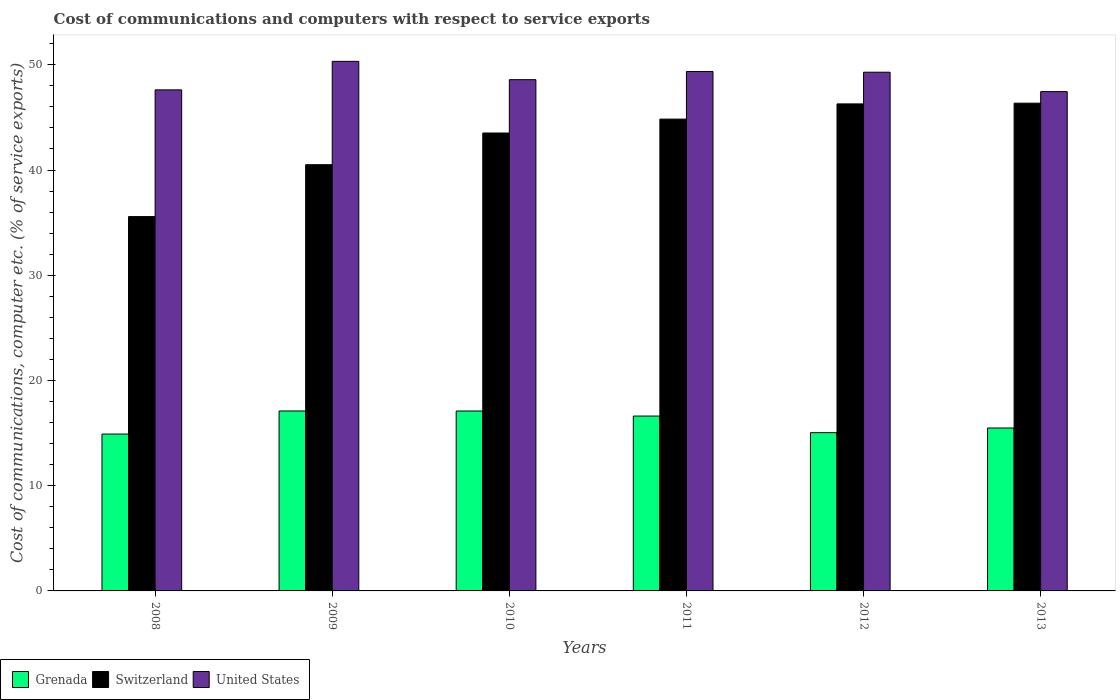How many different coloured bars are there?
Ensure brevity in your answer.  3. How many groups of bars are there?
Offer a very short reply. 6. How many bars are there on the 3rd tick from the right?
Provide a succinct answer. 3. What is the label of the 1st group of bars from the left?
Provide a succinct answer. 2008. In how many cases, is the number of bars for a given year not equal to the number of legend labels?
Provide a succinct answer. 0. What is the cost of communications and computers in United States in 2008?
Provide a succinct answer. 47.62. Across all years, what is the maximum cost of communications and computers in United States?
Your response must be concise. 50.33. Across all years, what is the minimum cost of communications and computers in Grenada?
Provide a short and direct response. 14.91. In which year was the cost of communications and computers in Grenada maximum?
Provide a succinct answer. 2009. What is the total cost of communications and computers in Grenada in the graph?
Offer a very short reply. 96.25. What is the difference between the cost of communications and computers in Grenada in 2009 and that in 2010?
Ensure brevity in your answer.  0. What is the difference between the cost of communications and computers in United States in 2009 and the cost of communications and computers in Switzerland in 2012?
Give a very brief answer. 4.04. What is the average cost of communications and computers in Grenada per year?
Provide a succinct answer. 16.04. In the year 2009, what is the difference between the cost of communications and computers in United States and cost of communications and computers in Grenada?
Provide a short and direct response. 33.23. In how many years, is the cost of communications and computers in Switzerland greater than 16 %?
Offer a very short reply. 6. What is the ratio of the cost of communications and computers in Grenada in 2011 to that in 2012?
Offer a terse response. 1.1. What is the difference between the highest and the second highest cost of communications and computers in Grenada?
Your response must be concise. 0. What is the difference between the highest and the lowest cost of communications and computers in Switzerland?
Your answer should be very brief. 10.78. Is the sum of the cost of communications and computers in United States in 2010 and 2012 greater than the maximum cost of communications and computers in Switzerland across all years?
Ensure brevity in your answer.  Yes. What does the 1st bar from the left in 2012 represents?
Keep it short and to the point. Grenada. What does the 3rd bar from the right in 2011 represents?
Ensure brevity in your answer.  Grenada. Is it the case that in every year, the sum of the cost of communications and computers in Grenada and cost of communications and computers in Switzerland is greater than the cost of communications and computers in United States?
Your answer should be very brief. Yes. How many bars are there?
Your response must be concise. 18. Are all the bars in the graph horizontal?
Ensure brevity in your answer.  No. How many years are there in the graph?
Make the answer very short. 6. Does the graph contain grids?
Offer a very short reply. No. How are the legend labels stacked?
Make the answer very short. Horizontal. What is the title of the graph?
Your answer should be compact. Cost of communications and computers with respect to service exports. What is the label or title of the X-axis?
Give a very brief answer. Years. What is the label or title of the Y-axis?
Provide a short and direct response. Cost of communications, computer etc. (% of service exports). What is the Cost of communications, computer etc. (% of service exports) in Grenada in 2008?
Your answer should be compact. 14.91. What is the Cost of communications, computer etc. (% of service exports) of Switzerland in 2008?
Your answer should be very brief. 35.58. What is the Cost of communications, computer etc. (% of service exports) of United States in 2008?
Your response must be concise. 47.62. What is the Cost of communications, computer etc. (% of service exports) in Grenada in 2009?
Offer a very short reply. 17.1. What is the Cost of communications, computer etc. (% of service exports) of Switzerland in 2009?
Give a very brief answer. 40.51. What is the Cost of communications, computer etc. (% of service exports) in United States in 2009?
Keep it short and to the point. 50.33. What is the Cost of communications, computer etc. (% of service exports) in Grenada in 2010?
Provide a succinct answer. 17.1. What is the Cost of communications, computer etc. (% of service exports) in Switzerland in 2010?
Provide a succinct answer. 43.52. What is the Cost of communications, computer etc. (% of service exports) of United States in 2010?
Your answer should be compact. 48.59. What is the Cost of communications, computer etc. (% of service exports) of Grenada in 2011?
Offer a terse response. 16.62. What is the Cost of communications, computer etc. (% of service exports) of Switzerland in 2011?
Make the answer very short. 44.84. What is the Cost of communications, computer etc. (% of service exports) of United States in 2011?
Your response must be concise. 49.37. What is the Cost of communications, computer etc. (% of service exports) of Grenada in 2012?
Make the answer very short. 15.04. What is the Cost of communications, computer etc. (% of service exports) of Switzerland in 2012?
Your answer should be compact. 46.29. What is the Cost of communications, computer etc. (% of service exports) of United States in 2012?
Provide a short and direct response. 49.3. What is the Cost of communications, computer etc. (% of service exports) of Grenada in 2013?
Make the answer very short. 15.48. What is the Cost of communications, computer etc. (% of service exports) of Switzerland in 2013?
Make the answer very short. 46.35. What is the Cost of communications, computer etc. (% of service exports) in United States in 2013?
Your answer should be very brief. 47.45. Across all years, what is the maximum Cost of communications, computer etc. (% of service exports) of Grenada?
Ensure brevity in your answer.  17.1. Across all years, what is the maximum Cost of communications, computer etc. (% of service exports) in Switzerland?
Your answer should be compact. 46.35. Across all years, what is the maximum Cost of communications, computer etc. (% of service exports) in United States?
Ensure brevity in your answer.  50.33. Across all years, what is the minimum Cost of communications, computer etc. (% of service exports) of Grenada?
Provide a short and direct response. 14.91. Across all years, what is the minimum Cost of communications, computer etc. (% of service exports) of Switzerland?
Your answer should be compact. 35.58. Across all years, what is the minimum Cost of communications, computer etc. (% of service exports) of United States?
Make the answer very short. 47.45. What is the total Cost of communications, computer etc. (% of service exports) in Grenada in the graph?
Make the answer very short. 96.25. What is the total Cost of communications, computer etc. (% of service exports) in Switzerland in the graph?
Offer a terse response. 257.08. What is the total Cost of communications, computer etc. (% of service exports) in United States in the graph?
Your answer should be compact. 292.66. What is the difference between the Cost of communications, computer etc. (% of service exports) of Grenada in 2008 and that in 2009?
Your answer should be compact. -2.19. What is the difference between the Cost of communications, computer etc. (% of service exports) in Switzerland in 2008 and that in 2009?
Your answer should be very brief. -4.93. What is the difference between the Cost of communications, computer etc. (% of service exports) of United States in 2008 and that in 2009?
Ensure brevity in your answer.  -2.71. What is the difference between the Cost of communications, computer etc. (% of service exports) in Grenada in 2008 and that in 2010?
Keep it short and to the point. -2.19. What is the difference between the Cost of communications, computer etc. (% of service exports) in Switzerland in 2008 and that in 2010?
Offer a terse response. -7.94. What is the difference between the Cost of communications, computer etc. (% of service exports) of United States in 2008 and that in 2010?
Offer a terse response. -0.97. What is the difference between the Cost of communications, computer etc. (% of service exports) in Grenada in 2008 and that in 2011?
Offer a very short reply. -1.71. What is the difference between the Cost of communications, computer etc. (% of service exports) in Switzerland in 2008 and that in 2011?
Offer a very short reply. -9.26. What is the difference between the Cost of communications, computer etc. (% of service exports) of United States in 2008 and that in 2011?
Make the answer very short. -1.75. What is the difference between the Cost of communications, computer etc. (% of service exports) in Grenada in 2008 and that in 2012?
Offer a terse response. -0.13. What is the difference between the Cost of communications, computer etc. (% of service exports) in Switzerland in 2008 and that in 2012?
Provide a short and direct response. -10.71. What is the difference between the Cost of communications, computer etc. (% of service exports) in United States in 2008 and that in 2012?
Your answer should be very brief. -1.68. What is the difference between the Cost of communications, computer etc. (% of service exports) of Grenada in 2008 and that in 2013?
Offer a very short reply. -0.58. What is the difference between the Cost of communications, computer etc. (% of service exports) of Switzerland in 2008 and that in 2013?
Provide a short and direct response. -10.78. What is the difference between the Cost of communications, computer etc. (% of service exports) of United States in 2008 and that in 2013?
Ensure brevity in your answer.  0.17. What is the difference between the Cost of communications, computer etc. (% of service exports) in Grenada in 2009 and that in 2010?
Make the answer very short. 0. What is the difference between the Cost of communications, computer etc. (% of service exports) of Switzerland in 2009 and that in 2010?
Make the answer very short. -3.01. What is the difference between the Cost of communications, computer etc. (% of service exports) of United States in 2009 and that in 2010?
Offer a very short reply. 1.74. What is the difference between the Cost of communications, computer etc. (% of service exports) of Grenada in 2009 and that in 2011?
Ensure brevity in your answer.  0.48. What is the difference between the Cost of communications, computer etc. (% of service exports) of Switzerland in 2009 and that in 2011?
Make the answer very short. -4.33. What is the difference between the Cost of communications, computer etc. (% of service exports) of United States in 2009 and that in 2011?
Your answer should be very brief. 0.96. What is the difference between the Cost of communications, computer etc. (% of service exports) in Grenada in 2009 and that in 2012?
Your answer should be compact. 2.06. What is the difference between the Cost of communications, computer etc. (% of service exports) of Switzerland in 2009 and that in 2012?
Your response must be concise. -5.78. What is the difference between the Cost of communications, computer etc. (% of service exports) of United States in 2009 and that in 2012?
Provide a short and direct response. 1.03. What is the difference between the Cost of communications, computer etc. (% of service exports) in Grenada in 2009 and that in 2013?
Your answer should be very brief. 1.62. What is the difference between the Cost of communications, computer etc. (% of service exports) in Switzerland in 2009 and that in 2013?
Offer a terse response. -5.85. What is the difference between the Cost of communications, computer etc. (% of service exports) in United States in 2009 and that in 2013?
Provide a short and direct response. 2.88. What is the difference between the Cost of communications, computer etc. (% of service exports) in Grenada in 2010 and that in 2011?
Your response must be concise. 0.48. What is the difference between the Cost of communications, computer etc. (% of service exports) of Switzerland in 2010 and that in 2011?
Your answer should be compact. -1.32. What is the difference between the Cost of communications, computer etc. (% of service exports) of United States in 2010 and that in 2011?
Give a very brief answer. -0.78. What is the difference between the Cost of communications, computer etc. (% of service exports) in Grenada in 2010 and that in 2012?
Ensure brevity in your answer.  2.06. What is the difference between the Cost of communications, computer etc. (% of service exports) in Switzerland in 2010 and that in 2012?
Make the answer very short. -2.77. What is the difference between the Cost of communications, computer etc. (% of service exports) in United States in 2010 and that in 2012?
Offer a terse response. -0.71. What is the difference between the Cost of communications, computer etc. (% of service exports) in Grenada in 2010 and that in 2013?
Provide a short and direct response. 1.61. What is the difference between the Cost of communications, computer etc. (% of service exports) of Switzerland in 2010 and that in 2013?
Keep it short and to the point. -2.84. What is the difference between the Cost of communications, computer etc. (% of service exports) of United States in 2010 and that in 2013?
Your answer should be compact. 1.14. What is the difference between the Cost of communications, computer etc. (% of service exports) of Grenada in 2011 and that in 2012?
Provide a short and direct response. 1.58. What is the difference between the Cost of communications, computer etc. (% of service exports) in Switzerland in 2011 and that in 2012?
Provide a succinct answer. -1.45. What is the difference between the Cost of communications, computer etc. (% of service exports) of United States in 2011 and that in 2012?
Keep it short and to the point. 0.07. What is the difference between the Cost of communications, computer etc. (% of service exports) in Grenada in 2011 and that in 2013?
Your answer should be very brief. 1.14. What is the difference between the Cost of communications, computer etc. (% of service exports) of Switzerland in 2011 and that in 2013?
Your answer should be compact. -1.52. What is the difference between the Cost of communications, computer etc. (% of service exports) in United States in 2011 and that in 2013?
Keep it short and to the point. 1.91. What is the difference between the Cost of communications, computer etc. (% of service exports) in Grenada in 2012 and that in 2013?
Keep it short and to the point. -0.44. What is the difference between the Cost of communications, computer etc. (% of service exports) of Switzerland in 2012 and that in 2013?
Ensure brevity in your answer.  -0.07. What is the difference between the Cost of communications, computer etc. (% of service exports) in United States in 2012 and that in 2013?
Your answer should be compact. 1.84. What is the difference between the Cost of communications, computer etc. (% of service exports) of Grenada in 2008 and the Cost of communications, computer etc. (% of service exports) of Switzerland in 2009?
Your response must be concise. -25.6. What is the difference between the Cost of communications, computer etc. (% of service exports) of Grenada in 2008 and the Cost of communications, computer etc. (% of service exports) of United States in 2009?
Your answer should be compact. -35.42. What is the difference between the Cost of communications, computer etc. (% of service exports) in Switzerland in 2008 and the Cost of communications, computer etc. (% of service exports) in United States in 2009?
Provide a succinct answer. -14.75. What is the difference between the Cost of communications, computer etc. (% of service exports) in Grenada in 2008 and the Cost of communications, computer etc. (% of service exports) in Switzerland in 2010?
Provide a succinct answer. -28.61. What is the difference between the Cost of communications, computer etc. (% of service exports) in Grenada in 2008 and the Cost of communications, computer etc. (% of service exports) in United States in 2010?
Make the answer very short. -33.68. What is the difference between the Cost of communications, computer etc. (% of service exports) of Switzerland in 2008 and the Cost of communications, computer etc. (% of service exports) of United States in 2010?
Provide a short and direct response. -13.01. What is the difference between the Cost of communications, computer etc. (% of service exports) of Grenada in 2008 and the Cost of communications, computer etc. (% of service exports) of Switzerland in 2011?
Offer a very short reply. -29.93. What is the difference between the Cost of communications, computer etc. (% of service exports) of Grenada in 2008 and the Cost of communications, computer etc. (% of service exports) of United States in 2011?
Your answer should be very brief. -34.46. What is the difference between the Cost of communications, computer etc. (% of service exports) of Switzerland in 2008 and the Cost of communications, computer etc. (% of service exports) of United States in 2011?
Your response must be concise. -13.79. What is the difference between the Cost of communications, computer etc. (% of service exports) in Grenada in 2008 and the Cost of communications, computer etc. (% of service exports) in Switzerland in 2012?
Offer a very short reply. -31.38. What is the difference between the Cost of communications, computer etc. (% of service exports) of Grenada in 2008 and the Cost of communications, computer etc. (% of service exports) of United States in 2012?
Provide a succinct answer. -34.39. What is the difference between the Cost of communications, computer etc. (% of service exports) in Switzerland in 2008 and the Cost of communications, computer etc. (% of service exports) in United States in 2012?
Offer a terse response. -13.72. What is the difference between the Cost of communications, computer etc. (% of service exports) of Grenada in 2008 and the Cost of communications, computer etc. (% of service exports) of Switzerland in 2013?
Make the answer very short. -31.45. What is the difference between the Cost of communications, computer etc. (% of service exports) in Grenada in 2008 and the Cost of communications, computer etc. (% of service exports) in United States in 2013?
Provide a succinct answer. -32.55. What is the difference between the Cost of communications, computer etc. (% of service exports) in Switzerland in 2008 and the Cost of communications, computer etc. (% of service exports) in United States in 2013?
Offer a terse response. -11.88. What is the difference between the Cost of communications, computer etc. (% of service exports) in Grenada in 2009 and the Cost of communications, computer etc. (% of service exports) in Switzerland in 2010?
Ensure brevity in your answer.  -26.42. What is the difference between the Cost of communications, computer etc. (% of service exports) in Grenada in 2009 and the Cost of communications, computer etc. (% of service exports) in United States in 2010?
Make the answer very short. -31.49. What is the difference between the Cost of communications, computer etc. (% of service exports) of Switzerland in 2009 and the Cost of communications, computer etc. (% of service exports) of United States in 2010?
Make the answer very short. -8.08. What is the difference between the Cost of communications, computer etc. (% of service exports) of Grenada in 2009 and the Cost of communications, computer etc. (% of service exports) of Switzerland in 2011?
Provide a short and direct response. -27.74. What is the difference between the Cost of communications, computer etc. (% of service exports) of Grenada in 2009 and the Cost of communications, computer etc. (% of service exports) of United States in 2011?
Your answer should be very brief. -32.26. What is the difference between the Cost of communications, computer etc. (% of service exports) of Switzerland in 2009 and the Cost of communications, computer etc. (% of service exports) of United States in 2011?
Your answer should be very brief. -8.86. What is the difference between the Cost of communications, computer etc. (% of service exports) of Grenada in 2009 and the Cost of communications, computer etc. (% of service exports) of Switzerland in 2012?
Your response must be concise. -29.18. What is the difference between the Cost of communications, computer etc. (% of service exports) in Grenada in 2009 and the Cost of communications, computer etc. (% of service exports) in United States in 2012?
Give a very brief answer. -32.2. What is the difference between the Cost of communications, computer etc. (% of service exports) in Switzerland in 2009 and the Cost of communications, computer etc. (% of service exports) in United States in 2012?
Give a very brief answer. -8.79. What is the difference between the Cost of communications, computer etc. (% of service exports) in Grenada in 2009 and the Cost of communications, computer etc. (% of service exports) in Switzerland in 2013?
Ensure brevity in your answer.  -29.25. What is the difference between the Cost of communications, computer etc. (% of service exports) of Grenada in 2009 and the Cost of communications, computer etc. (% of service exports) of United States in 2013?
Offer a terse response. -30.35. What is the difference between the Cost of communications, computer etc. (% of service exports) of Switzerland in 2009 and the Cost of communications, computer etc. (% of service exports) of United States in 2013?
Ensure brevity in your answer.  -6.95. What is the difference between the Cost of communications, computer etc. (% of service exports) in Grenada in 2010 and the Cost of communications, computer etc. (% of service exports) in Switzerland in 2011?
Provide a succinct answer. -27.74. What is the difference between the Cost of communications, computer etc. (% of service exports) of Grenada in 2010 and the Cost of communications, computer etc. (% of service exports) of United States in 2011?
Ensure brevity in your answer.  -32.27. What is the difference between the Cost of communications, computer etc. (% of service exports) of Switzerland in 2010 and the Cost of communications, computer etc. (% of service exports) of United States in 2011?
Provide a succinct answer. -5.85. What is the difference between the Cost of communications, computer etc. (% of service exports) of Grenada in 2010 and the Cost of communications, computer etc. (% of service exports) of Switzerland in 2012?
Make the answer very short. -29.19. What is the difference between the Cost of communications, computer etc. (% of service exports) of Grenada in 2010 and the Cost of communications, computer etc. (% of service exports) of United States in 2012?
Provide a short and direct response. -32.2. What is the difference between the Cost of communications, computer etc. (% of service exports) of Switzerland in 2010 and the Cost of communications, computer etc. (% of service exports) of United States in 2012?
Provide a succinct answer. -5.78. What is the difference between the Cost of communications, computer etc. (% of service exports) of Grenada in 2010 and the Cost of communications, computer etc. (% of service exports) of Switzerland in 2013?
Your answer should be compact. -29.26. What is the difference between the Cost of communications, computer etc. (% of service exports) of Grenada in 2010 and the Cost of communications, computer etc. (% of service exports) of United States in 2013?
Your answer should be very brief. -30.36. What is the difference between the Cost of communications, computer etc. (% of service exports) of Switzerland in 2010 and the Cost of communications, computer etc. (% of service exports) of United States in 2013?
Keep it short and to the point. -3.93. What is the difference between the Cost of communications, computer etc. (% of service exports) in Grenada in 2011 and the Cost of communications, computer etc. (% of service exports) in Switzerland in 2012?
Your response must be concise. -29.67. What is the difference between the Cost of communications, computer etc. (% of service exports) of Grenada in 2011 and the Cost of communications, computer etc. (% of service exports) of United States in 2012?
Ensure brevity in your answer.  -32.68. What is the difference between the Cost of communications, computer etc. (% of service exports) in Switzerland in 2011 and the Cost of communications, computer etc. (% of service exports) in United States in 2012?
Provide a succinct answer. -4.46. What is the difference between the Cost of communications, computer etc. (% of service exports) in Grenada in 2011 and the Cost of communications, computer etc. (% of service exports) in Switzerland in 2013?
Your answer should be compact. -29.73. What is the difference between the Cost of communications, computer etc. (% of service exports) of Grenada in 2011 and the Cost of communications, computer etc. (% of service exports) of United States in 2013?
Your response must be concise. -30.83. What is the difference between the Cost of communications, computer etc. (% of service exports) in Switzerland in 2011 and the Cost of communications, computer etc. (% of service exports) in United States in 2013?
Make the answer very short. -2.61. What is the difference between the Cost of communications, computer etc. (% of service exports) of Grenada in 2012 and the Cost of communications, computer etc. (% of service exports) of Switzerland in 2013?
Give a very brief answer. -31.31. What is the difference between the Cost of communications, computer etc. (% of service exports) in Grenada in 2012 and the Cost of communications, computer etc. (% of service exports) in United States in 2013?
Your response must be concise. -32.41. What is the difference between the Cost of communications, computer etc. (% of service exports) in Switzerland in 2012 and the Cost of communications, computer etc. (% of service exports) in United States in 2013?
Offer a terse response. -1.17. What is the average Cost of communications, computer etc. (% of service exports) in Grenada per year?
Provide a succinct answer. 16.04. What is the average Cost of communications, computer etc. (% of service exports) in Switzerland per year?
Offer a very short reply. 42.85. What is the average Cost of communications, computer etc. (% of service exports) in United States per year?
Provide a short and direct response. 48.78. In the year 2008, what is the difference between the Cost of communications, computer etc. (% of service exports) in Grenada and Cost of communications, computer etc. (% of service exports) in Switzerland?
Keep it short and to the point. -20.67. In the year 2008, what is the difference between the Cost of communications, computer etc. (% of service exports) of Grenada and Cost of communications, computer etc. (% of service exports) of United States?
Make the answer very short. -32.71. In the year 2008, what is the difference between the Cost of communications, computer etc. (% of service exports) of Switzerland and Cost of communications, computer etc. (% of service exports) of United States?
Offer a very short reply. -12.04. In the year 2009, what is the difference between the Cost of communications, computer etc. (% of service exports) in Grenada and Cost of communications, computer etc. (% of service exports) in Switzerland?
Give a very brief answer. -23.41. In the year 2009, what is the difference between the Cost of communications, computer etc. (% of service exports) in Grenada and Cost of communications, computer etc. (% of service exports) in United States?
Your answer should be very brief. -33.23. In the year 2009, what is the difference between the Cost of communications, computer etc. (% of service exports) of Switzerland and Cost of communications, computer etc. (% of service exports) of United States?
Your answer should be very brief. -9.82. In the year 2010, what is the difference between the Cost of communications, computer etc. (% of service exports) in Grenada and Cost of communications, computer etc. (% of service exports) in Switzerland?
Keep it short and to the point. -26.42. In the year 2010, what is the difference between the Cost of communications, computer etc. (% of service exports) of Grenada and Cost of communications, computer etc. (% of service exports) of United States?
Offer a very short reply. -31.49. In the year 2010, what is the difference between the Cost of communications, computer etc. (% of service exports) in Switzerland and Cost of communications, computer etc. (% of service exports) in United States?
Your answer should be very brief. -5.07. In the year 2011, what is the difference between the Cost of communications, computer etc. (% of service exports) in Grenada and Cost of communications, computer etc. (% of service exports) in Switzerland?
Offer a terse response. -28.22. In the year 2011, what is the difference between the Cost of communications, computer etc. (% of service exports) of Grenada and Cost of communications, computer etc. (% of service exports) of United States?
Give a very brief answer. -32.75. In the year 2011, what is the difference between the Cost of communications, computer etc. (% of service exports) in Switzerland and Cost of communications, computer etc. (% of service exports) in United States?
Offer a terse response. -4.53. In the year 2012, what is the difference between the Cost of communications, computer etc. (% of service exports) in Grenada and Cost of communications, computer etc. (% of service exports) in Switzerland?
Make the answer very short. -31.24. In the year 2012, what is the difference between the Cost of communications, computer etc. (% of service exports) in Grenada and Cost of communications, computer etc. (% of service exports) in United States?
Provide a succinct answer. -34.26. In the year 2012, what is the difference between the Cost of communications, computer etc. (% of service exports) of Switzerland and Cost of communications, computer etc. (% of service exports) of United States?
Your response must be concise. -3.01. In the year 2013, what is the difference between the Cost of communications, computer etc. (% of service exports) in Grenada and Cost of communications, computer etc. (% of service exports) in Switzerland?
Keep it short and to the point. -30.87. In the year 2013, what is the difference between the Cost of communications, computer etc. (% of service exports) of Grenada and Cost of communications, computer etc. (% of service exports) of United States?
Your answer should be compact. -31.97. In the year 2013, what is the difference between the Cost of communications, computer etc. (% of service exports) in Switzerland and Cost of communications, computer etc. (% of service exports) in United States?
Keep it short and to the point. -1.1. What is the ratio of the Cost of communications, computer etc. (% of service exports) of Grenada in 2008 to that in 2009?
Keep it short and to the point. 0.87. What is the ratio of the Cost of communications, computer etc. (% of service exports) of Switzerland in 2008 to that in 2009?
Ensure brevity in your answer.  0.88. What is the ratio of the Cost of communications, computer etc. (% of service exports) of United States in 2008 to that in 2009?
Make the answer very short. 0.95. What is the ratio of the Cost of communications, computer etc. (% of service exports) of Grenada in 2008 to that in 2010?
Keep it short and to the point. 0.87. What is the ratio of the Cost of communications, computer etc. (% of service exports) in Switzerland in 2008 to that in 2010?
Provide a succinct answer. 0.82. What is the ratio of the Cost of communications, computer etc. (% of service exports) in Grenada in 2008 to that in 2011?
Offer a terse response. 0.9. What is the ratio of the Cost of communications, computer etc. (% of service exports) of Switzerland in 2008 to that in 2011?
Provide a short and direct response. 0.79. What is the ratio of the Cost of communications, computer etc. (% of service exports) in United States in 2008 to that in 2011?
Keep it short and to the point. 0.96. What is the ratio of the Cost of communications, computer etc. (% of service exports) of Grenada in 2008 to that in 2012?
Provide a short and direct response. 0.99. What is the ratio of the Cost of communications, computer etc. (% of service exports) in Switzerland in 2008 to that in 2012?
Offer a terse response. 0.77. What is the ratio of the Cost of communications, computer etc. (% of service exports) in Grenada in 2008 to that in 2013?
Offer a terse response. 0.96. What is the ratio of the Cost of communications, computer etc. (% of service exports) of Switzerland in 2008 to that in 2013?
Ensure brevity in your answer.  0.77. What is the ratio of the Cost of communications, computer etc. (% of service exports) of United States in 2008 to that in 2013?
Give a very brief answer. 1. What is the ratio of the Cost of communications, computer etc. (% of service exports) in Grenada in 2009 to that in 2010?
Your answer should be very brief. 1. What is the ratio of the Cost of communications, computer etc. (% of service exports) of Switzerland in 2009 to that in 2010?
Your answer should be very brief. 0.93. What is the ratio of the Cost of communications, computer etc. (% of service exports) in United States in 2009 to that in 2010?
Provide a succinct answer. 1.04. What is the ratio of the Cost of communications, computer etc. (% of service exports) of Grenada in 2009 to that in 2011?
Ensure brevity in your answer.  1.03. What is the ratio of the Cost of communications, computer etc. (% of service exports) in Switzerland in 2009 to that in 2011?
Provide a short and direct response. 0.9. What is the ratio of the Cost of communications, computer etc. (% of service exports) in United States in 2009 to that in 2011?
Your response must be concise. 1.02. What is the ratio of the Cost of communications, computer etc. (% of service exports) in Grenada in 2009 to that in 2012?
Provide a succinct answer. 1.14. What is the ratio of the Cost of communications, computer etc. (% of service exports) of Switzerland in 2009 to that in 2012?
Offer a very short reply. 0.88. What is the ratio of the Cost of communications, computer etc. (% of service exports) of United States in 2009 to that in 2012?
Your answer should be very brief. 1.02. What is the ratio of the Cost of communications, computer etc. (% of service exports) in Grenada in 2009 to that in 2013?
Your answer should be very brief. 1.1. What is the ratio of the Cost of communications, computer etc. (% of service exports) of Switzerland in 2009 to that in 2013?
Your response must be concise. 0.87. What is the ratio of the Cost of communications, computer etc. (% of service exports) in United States in 2009 to that in 2013?
Offer a very short reply. 1.06. What is the ratio of the Cost of communications, computer etc. (% of service exports) in Grenada in 2010 to that in 2011?
Ensure brevity in your answer.  1.03. What is the ratio of the Cost of communications, computer etc. (% of service exports) of Switzerland in 2010 to that in 2011?
Keep it short and to the point. 0.97. What is the ratio of the Cost of communications, computer etc. (% of service exports) in United States in 2010 to that in 2011?
Your answer should be compact. 0.98. What is the ratio of the Cost of communications, computer etc. (% of service exports) of Grenada in 2010 to that in 2012?
Keep it short and to the point. 1.14. What is the ratio of the Cost of communications, computer etc. (% of service exports) of Switzerland in 2010 to that in 2012?
Give a very brief answer. 0.94. What is the ratio of the Cost of communications, computer etc. (% of service exports) of United States in 2010 to that in 2012?
Your response must be concise. 0.99. What is the ratio of the Cost of communications, computer etc. (% of service exports) of Grenada in 2010 to that in 2013?
Provide a succinct answer. 1.1. What is the ratio of the Cost of communications, computer etc. (% of service exports) in Switzerland in 2010 to that in 2013?
Your answer should be very brief. 0.94. What is the ratio of the Cost of communications, computer etc. (% of service exports) of United States in 2010 to that in 2013?
Give a very brief answer. 1.02. What is the ratio of the Cost of communications, computer etc. (% of service exports) of Grenada in 2011 to that in 2012?
Give a very brief answer. 1.1. What is the ratio of the Cost of communications, computer etc. (% of service exports) of Switzerland in 2011 to that in 2012?
Offer a very short reply. 0.97. What is the ratio of the Cost of communications, computer etc. (% of service exports) in United States in 2011 to that in 2012?
Offer a terse response. 1. What is the ratio of the Cost of communications, computer etc. (% of service exports) of Grenada in 2011 to that in 2013?
Keep it short and to the point. 1.07. What is the ratio of the Cost of communications, computer etc. (% of service exports) in Switzerland in 2011 to that in 2013?
Offer a terse response. 0.97. What is the ratio of the Cost of communications, computer etc. (% of service exports) in United States in 2011 to that in 2013?
Provide a short and direct response. 1.04. What is the ratio of the Cost of communications, computer etc. (% of service exports) in Grenada in 2012 to that in 2013?
Your answer should be compact. 0.97. What is the ratio of the Cost of communications, computer etc. (% of service exports) in United States in 2012 to that in 2013?
Ensure brevity in your answer.  1.04. What is the difference between the highest and the second highest Cost of communications, computer etc. (% of service exports) in Grenada?
Give a very brief answer. 0. What is the difference between the highest and the second highest Cost of communications, computer etc. (% of service exports) of Switzerland?
Offer a very short reply. 0.07. What is the difference between the highest and the second highest Cost of communications, computer etc. (% of service exports) in United States?
Offer a terse response. 0.96. What is the difference between the highest and the lowest Cost of communications, computer etc. (% of service exports) in Grenada?
Give a very brief answer. 2.19. What is the difference between the highest and the lowest Cost of communications, computer etc. (% of service exports) in Switzerland?
Give a very brief answer. 10.78. What is the difference between the highest and the lowest Cost of communications, computer etc. (% of service exports) of United States?
Offer a terse response. 2.88. 